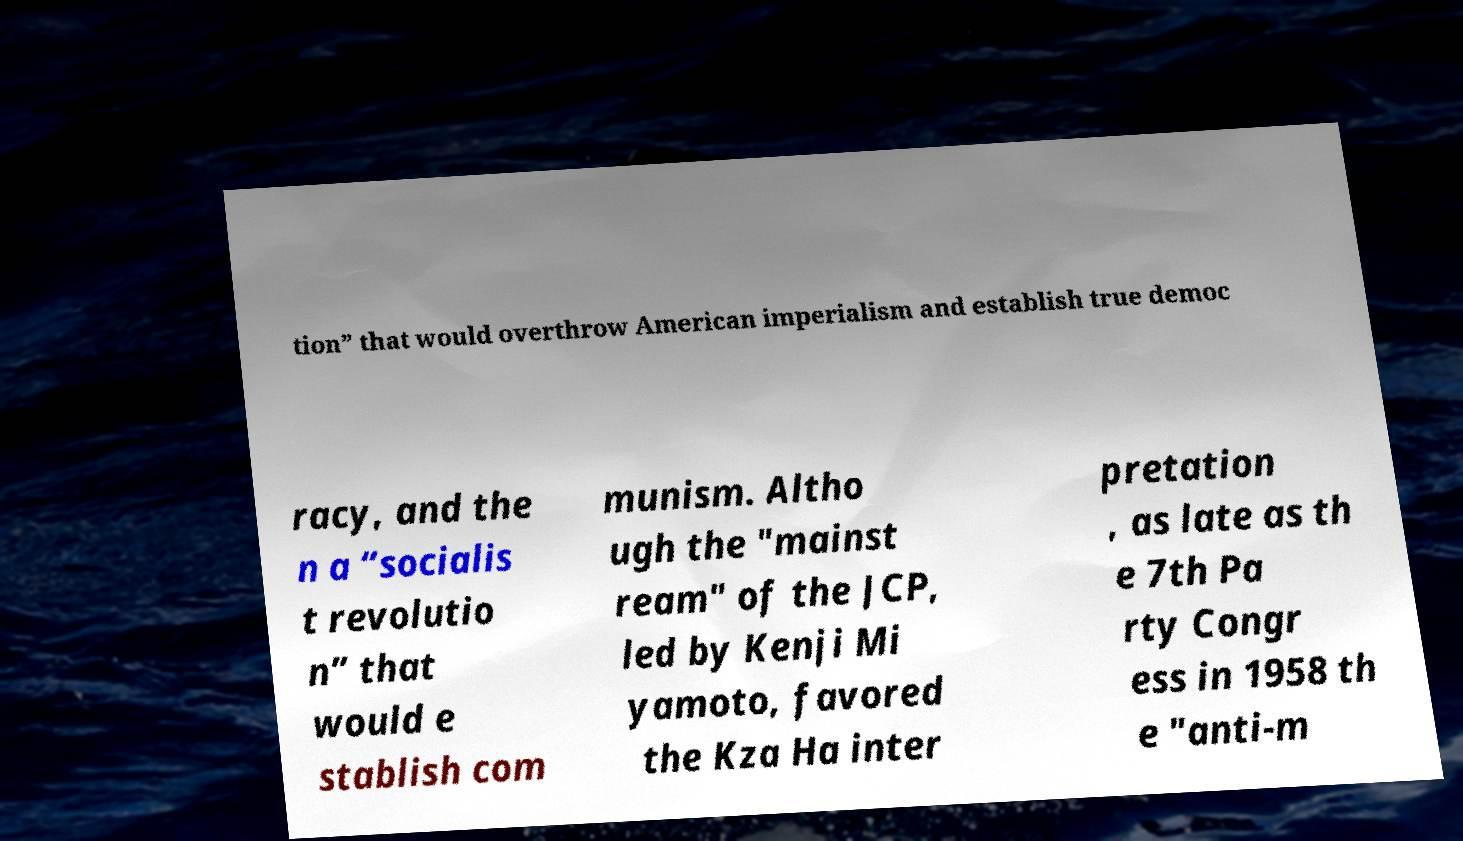There's text embedded in this image that I need extracted. Can you transcribe it verbatim? tion” that would overthrow American imperialism and establish true democ racy, and the n a “socialis t revolutio n” that would e stablish com munism. Altho ugh the "mainst ream" of the JCP, led by Kenji Mi yamoto, favored the Kza Ha inter pretation , as late as th e 7th Pa rty Congr ess in 1958 th e "anti-m 